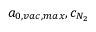<formula> <loc_0><loc_0><loc_500><loc_500>a _ { 0 , v a c , \max } , c _ { N _ { 2 } }</formula> 